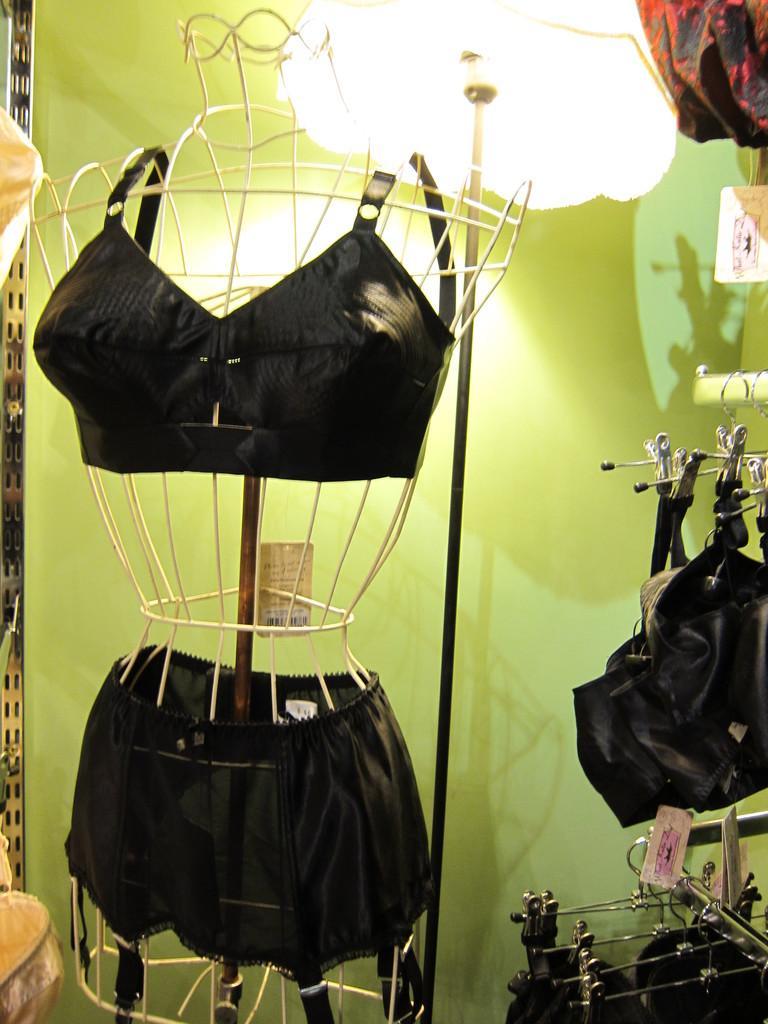Describe this image in one or two sentences. In this picture there is a dress on the object. On the right side of the image there are clothes on the rod. At the back there is a lamp and wall. 